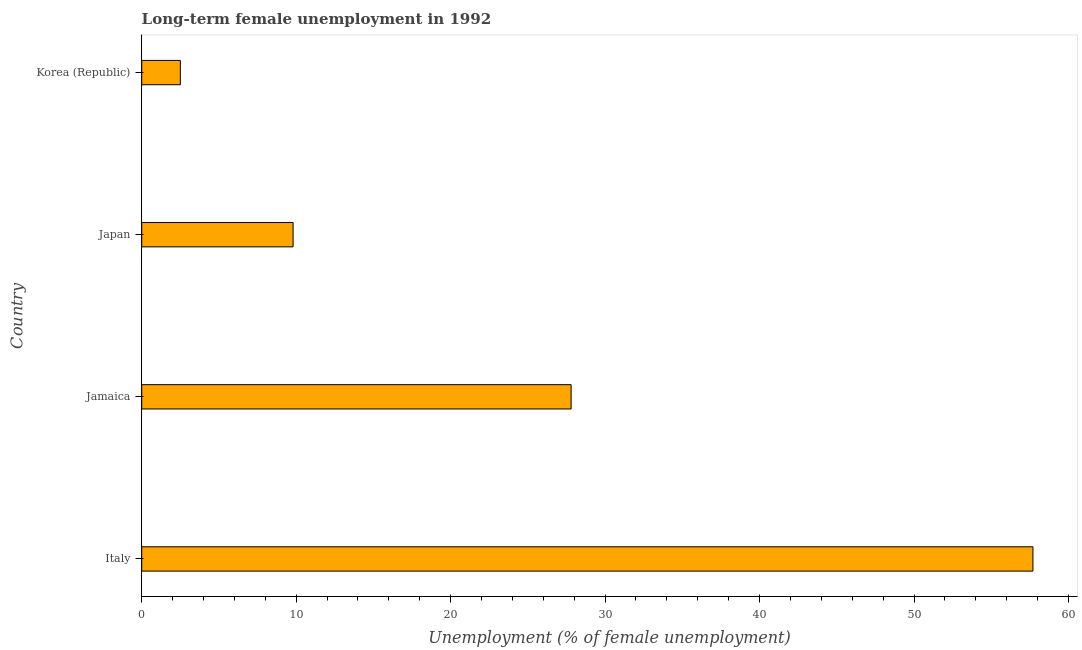Does the graph contain grids?
Make the answer very short. No. What is the title of the graph?
Offer a terse response. Long-term female unemployment in 1992. What is the label or title of the X-axis?
Provide a succinct answer. Unemployment (% of female unemployment). What is the label or title of the Y-axis?
Your response must be concise. Country. What is the long-term female unemployment in Japan?
Keep it short and to the point. 9.8. Across all countries, what is the maximum long-term female unemployment?
Your answer should be compact. 57.7. Across all countries, what is the minimum long-term female unemployment?
Provide a short and direct response. 2.5. In which country was the long-term female unemployment maximum?
Your answer should be very brief. Italy. In which country was the long-term female unemployment minimum?
Give a very brief answer. Korea (Republic). What is the sum of the long-term female unemployment?
Keep it short and to the point. 97.8. What is the difference between the long-term female unemployment in Italy and Korea (Republic)?
Offer a very short reply. 55.2. What is the average long-term female unemployment per country?
Your answer should be compact. 24.45. What is the median long-term female unemployment?
Keep it short and to the point. 18.8. What is the ratio of the long-term female unemployment in Italy to that in Jamaica?
Your answer should be compact. 2.08. Is the long-term female unemployment in Italy less than that in Jamaica?
Give a very brief answer. No. Is the difference between the long-term female unemployment in Jamaica and Korea (Republic) greater than the difference between any two countries?
Offer a very short reply. No. What is the difference between the highest and the second highest long-term female unemployment?
Ensure brevity in your answer.  29.9. What is the difference between the highest and the lowest long-term female unemployment?
Give a very brief answer. 55.2. Are all the bars in the graph horizontal?
Offer a very short reply. Yes. What is the Unemployment (% of female unemployment) in Italy?
Give a very brief answer. 57.7. What is the Unemployment (% of female unemployment) of Jamaica?
Keep it short and to the point. 27.8. What is the Unemployment (% of female unemployment) in Japan?
Your answer should be very brief. 9.8. What is the Unemployment (% of female unemployment) of Korea (Republic)?
Provide a succinct answer. 2.5. What is the difference between the Unemployment (% of female unemployment) in Italy and Jamaica?
Ensure brevity in your answer.  29.9. What is the difference between the Unemployment (% of female unemployment) in Italy and Japan?
Ensure brevity in your answer.  47.9. What is the difference between the Unemployment (% of female unemployment) in Italy and Korea (Republic)?
Your answer should be compact. 55.2. What is the difference between the Unemployment (% of female unemployment) in Jamaica and Japan?
Keep it short and to the point. 18. What is the difference between the Unemployment (% of female unemployment) in Jamaica and Korea (Republic)?
Provide a succinct answer. 25.3. What is the ratio of the Unemployment (% of female unemployment) in Italy to that in Jamaica?
Offer a terse response. 2.08. What is the ratio of the Unemployment (% of female unemployment) in Italy to that in Japan?
Your answer should be very brief. 5.89. What is the ratio of the Unemployment (% of female unemployment) in Italy to that in Korea (Republic)?
Your answer should be compact. 23.08. What is the ratio of the Unemployment (% of female unemployment) in Jamaica to that in Japan?
Your response must be concise. 2.84. What is the ratio of the Unemployment (% of female unemployment) in Jamaica to that in Korea (Republic)?
Offer a very short reply. 11.12. What is the ratio of the Unemployment (% of female unemployment) in Japan to that in Korea (Republic)?
Your response must be concise. 3.92. 